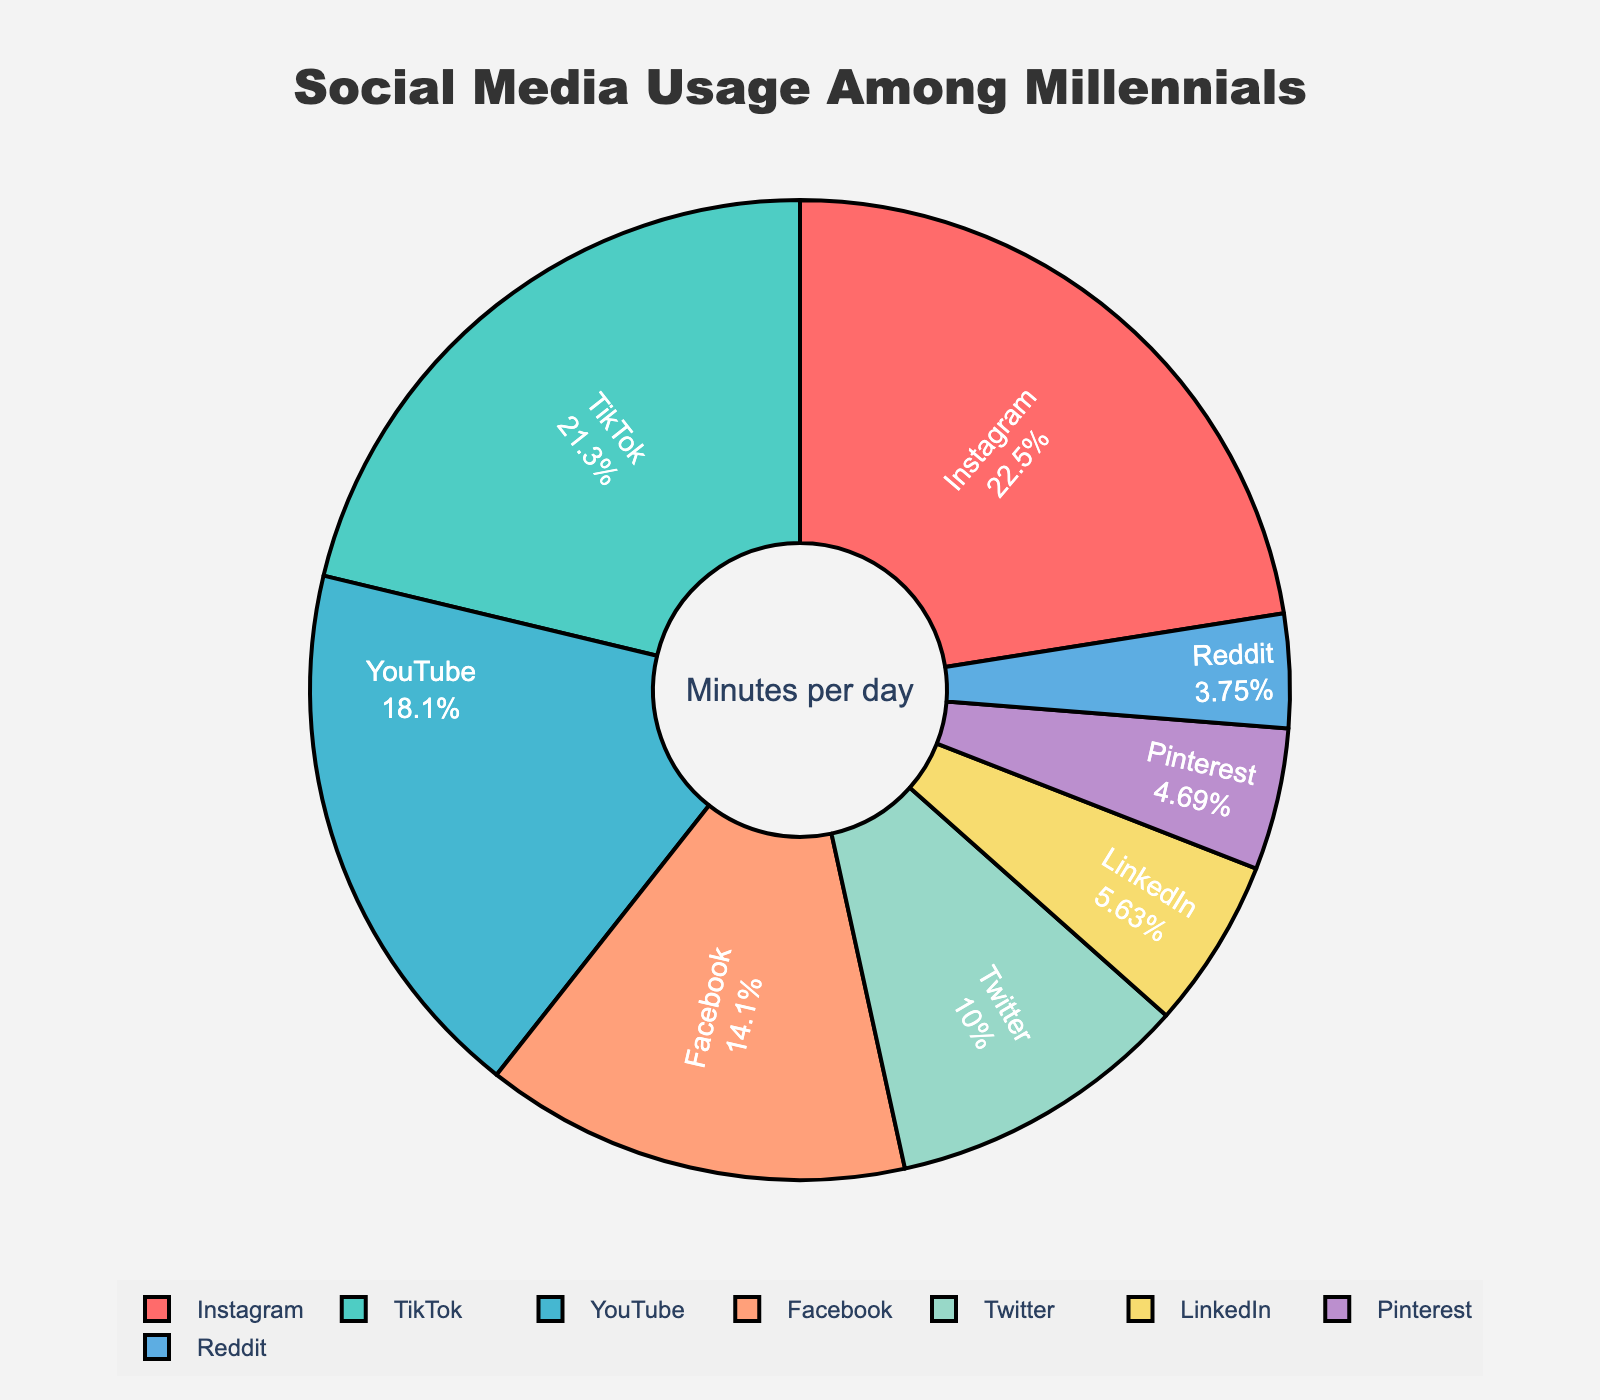Which platform has the highest usage among millennials? The chart shows the percentage of time spent on each platform. The platform with the highest percentage is Instagram, which also has the highest number of minutes per day, 72.
Answer: Instagram What percentage of time is spent on YouTube? The chart labels and percentages associated with each segment show that YouTube occupies a certain portion of the pie chart. By looking at YouTube, we see it has 58 minutes/day. It translates to approximately 21% of the total.
Answer: 21% How much more time do millennials spend on Instagram compared to LinkedIn? The pie chart shows 72 minutes/day for Instagram and 18 minutes/day for LinkedIn. By subtracting LinkedIn's usage from Instagram's, we get 72 - 18 = 54 minutes.
Answer: 54 minutes What is the total time spent on TikTok and Reddit combined? The chart shows TikTok at 68 minutes/day and Reddit at 12 minutes/day. Adding these together gives 68 + 12 = 80 minutes.
Answer: 80 minutes Which platform has the least usage? The pie chart and the number of minutes per day indicate the smallest segment. Pinterest has 15 minutes/day, but Reddit, with 12 minutes/day, has the least usage.
Answer: Reddit How much time do millennials spend on Instagram, YouTube, and Facebook combined? The minutes per day in the chart are 72 for Instagram, 58 for YouTube, and 45 for Facebook. Adding them together gives 72 + 58 + 45 = 175 minutes.
Answer: 175 minutes Which platform usage is closest to that of Facebook? The pie chart shows Facebook usage as 45 minutes/day. Comparing with other platforms, Twitter has 32 minutes/day, which is the closest.
Answer: Twitter What is the difference in percentage usage between Twitter and LinkedIn? Twitter is 32 minutes/day, and LinkedIn is 18 minutes/day. Their total usage of 215 minutes (all platforms combined) gives approximately 15% for Twitter and 8% for LinkedIn. The difference is 15% - 8% = 7%.
Answer: 7% What percentage of total time is spent on Instagram and TikTok together? Instagram is 72 minutes/day and TikTok 68 minutes/day. That totals 140 minutes/day of the 320 minutes (total for all platforms), yielding 140/320 = 43.75%.
Answer: 43.75% What is the average usage time across all platforms? Sum the minutes per day (72 + 68 + 58 + 45 + 32 + 18 + 15 + 12 = 320 minutes) and divide by the number of platforms (8). The average is 320/8 = 40 minutes.
Answer: 40 minutes 